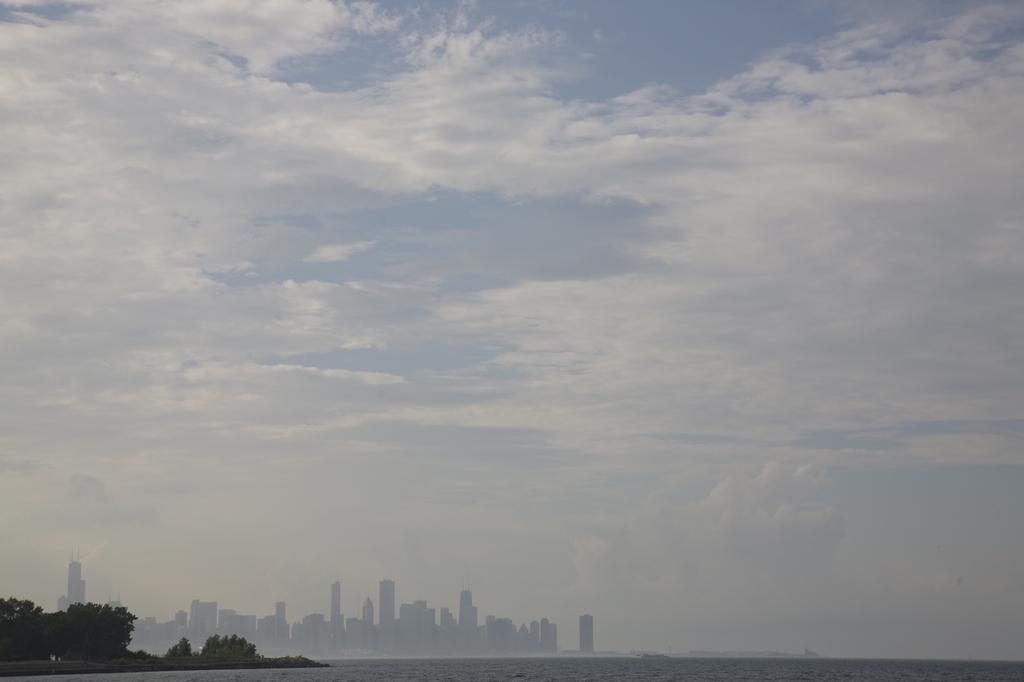Describe this image in one or two sentences. In this image, we can see the cloudy sky. At the bottom of the image, we can see the water, trees and buildings. 